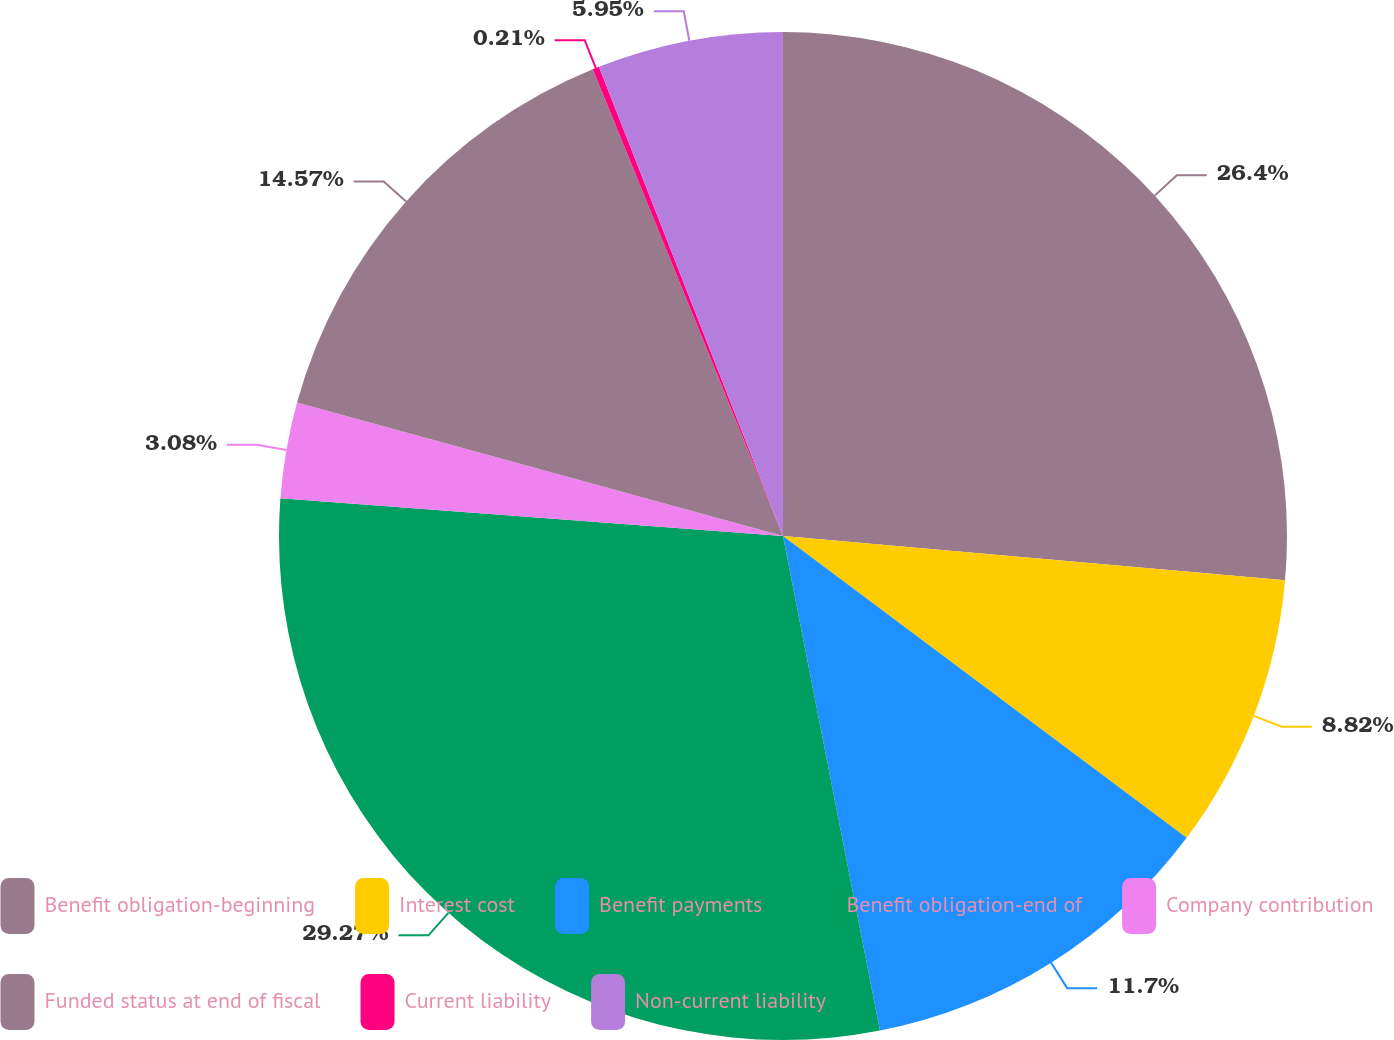Convert chart. <chart><loc_0><loc_0><loc_500><loc_500><pie_chart><fcel>Benefit obligation-beginning<fcel>Interest cost<fcel>Benefit payments<fcel>Benefit obligation-end of<fcel>Company contribution<fcel>Funded status at end of fiscal<fcel>Current liability<fcel>Non-current liability<nl><fcel>26.4%<fcel>8.82%<fcel>11.7%<fcel>29.27%<fcel>3.08%<fcel>14.57%<fcel>0.21%<fcel>5.95%<nl></chart> 